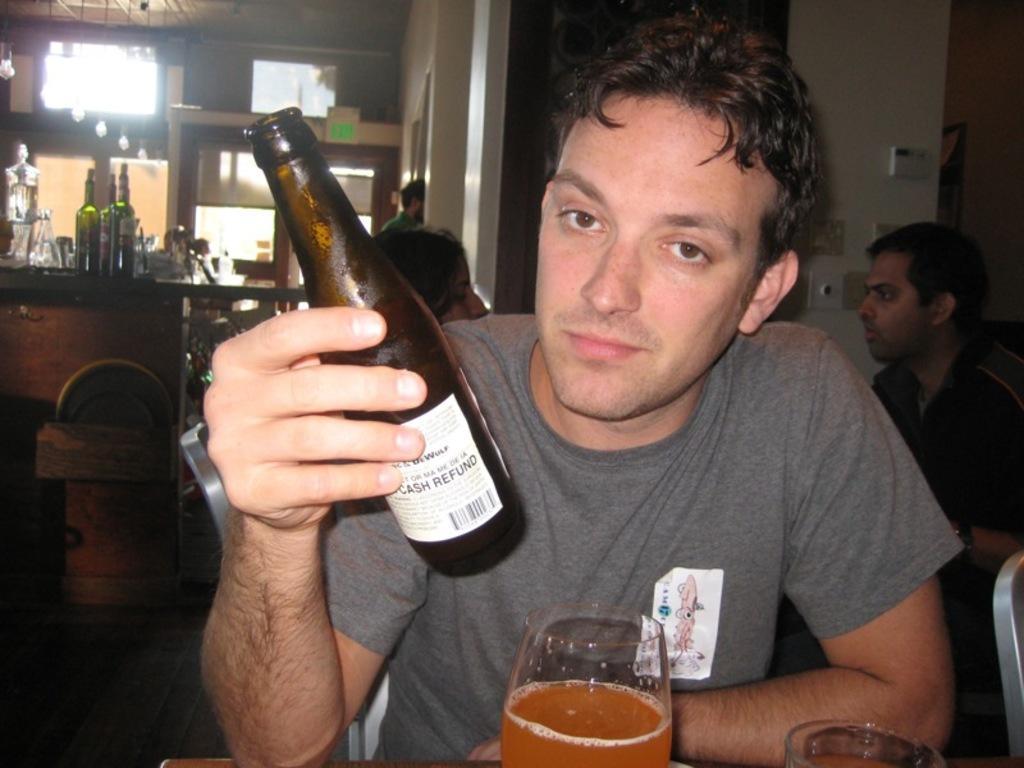Can you describe this image briefly? In the picture i could see person holding a bottle in his hand and juice glass in front of him. In the background there are many persons standing and moving all around and i could see some bottles kept on the counter top. 